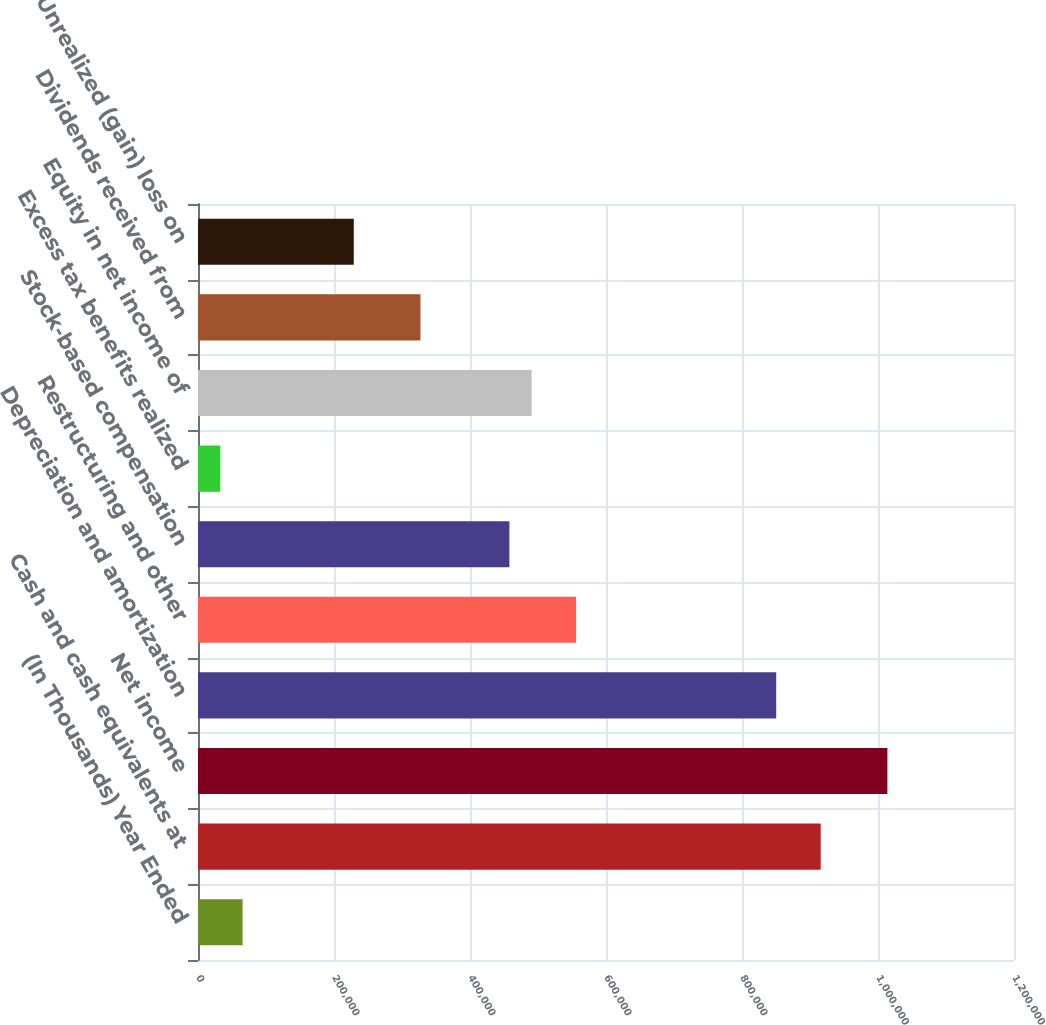<chart> <loc_0><loc_0><loc_500><loc_500><bar_chart><fcel>(In Thousands) Year Ended<fcel>Cash and cash equivalents at<fcel>Net income<fcel>Depreciation and amortization<fcel>Restructuring and other<fcel>Stock-based compensation<fcel>Excess tax benefits realized<fcel>Equity in net income of<fcel>Dividends received from<fcel>Unrealized (gain) loss on<nl><fcel>65583.6<fcel>915700<fcel>1.01379e+06<fcel>850307<fcel>556036<fcel>457945<fcel>32886.8<fcel>490642<fcel>327158<fcel>229068<nl></chart> 